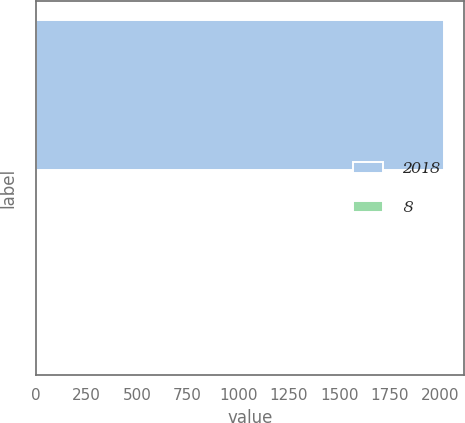Convert chart. <chart><loc_0><loc_0><loc_500><loc_500><bar_chart><fcel>2018<fcel>8<nl><fcel>2016<fcel>1<nl></chart> 